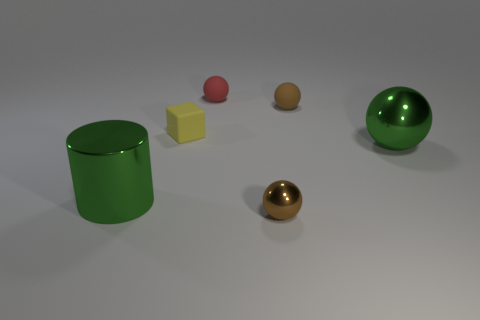How many other objects are there of the same shape as the small yellow matte thing?
Make the answer very short. 0. Is there any other thing that is the same color as the large ball?
Your answer should be compact. Yes. What shape is the brown thing that is the same material as the red object?
Provide a short and direct response. Sphere. Is the material of the green thing to the left of the red sphere the same as the green ball?
Offer a very short reply. Yes. There is a big metallic thing that is the same color as the large ball; what shape is it?
Provide a succinct answer. Cylinder. Is the color of the big metallic object that is to the left of the yellow cube the same as the rubber ball left of the tiny brown shiny object?
Your response must be concise. No. What number of small brown balls are both behind the yellow thing and in front of the yellow object?
Give a very brief answer. 0. What is the material of the large green sphere?
Ensure brevity in your answer.  Metal. The yellow object that is the same size as the red rubber ball is what shape?
Offer a very short reply. Cube. Does the brown thing that is in front of the green metallic sphere have the same material as the brown thing that is to the right of the small brown shiny thing?
Your answer should be compact. No. 